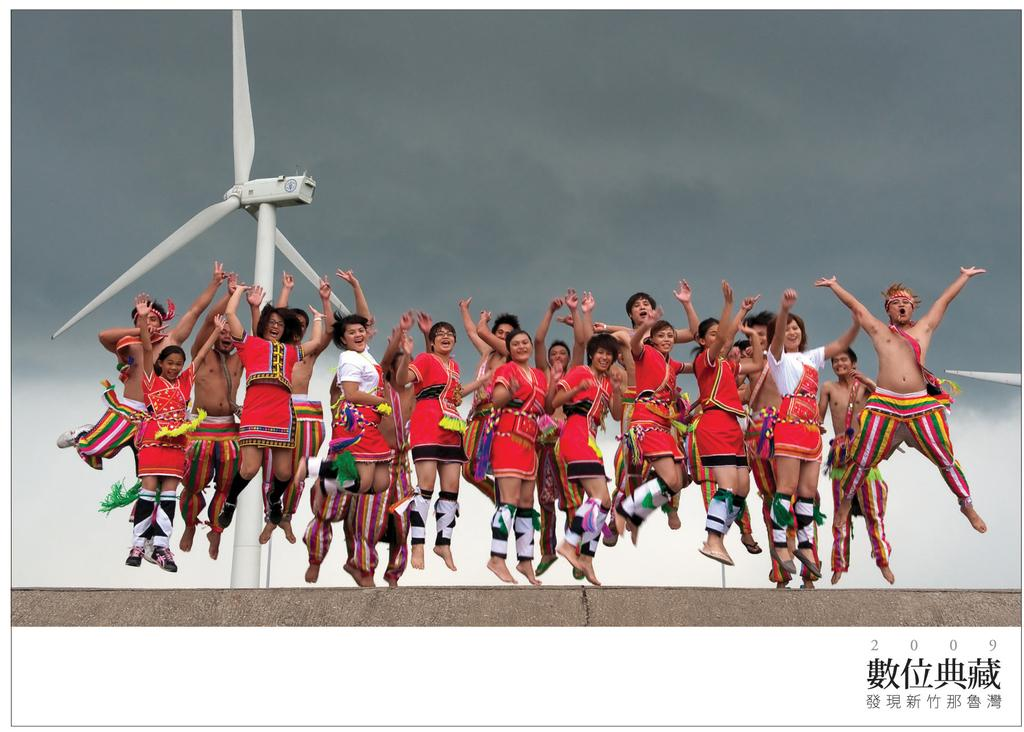What is happening with the groups of people in the image? The people are jumping on a path in the image. What can be seen in the background of the image? There is a wind turbine in the background of the image. What is the condition of the sky in the image? The sky is cloudy in the image. Can you describe any additional features of the image? There is a watermark on the image. What type of rice is being used to create the path on which the people are jumping? There is no rice present in the image; the path is not made of rice. 